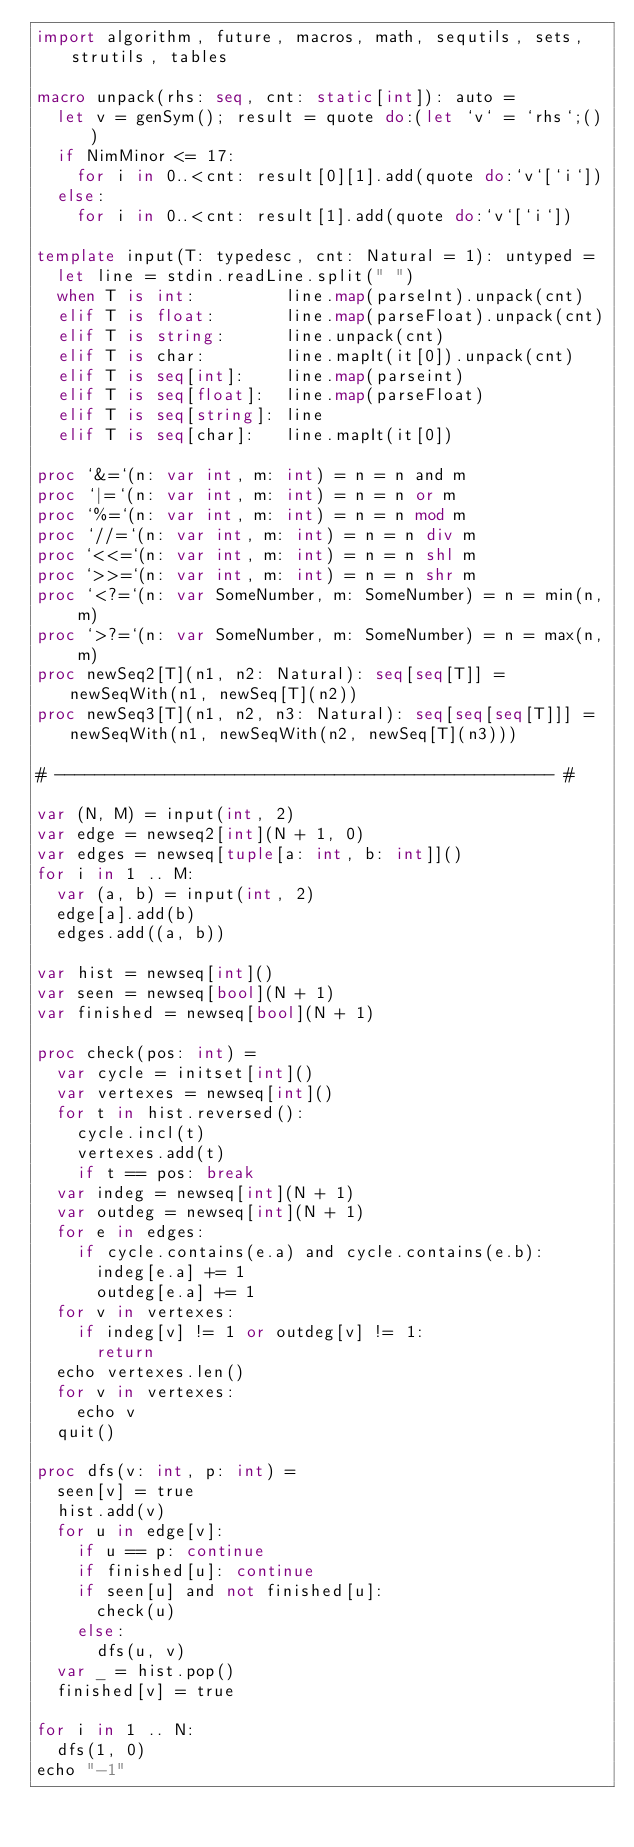<code> <loc_0><loc_0><loc_500><loc_500><_Nim_>import algorithm, future, macros, math, sequtils, sets, strutils, tables

macro unpack(rhs: seq, cnt: static[int]): auto =
  let v = genSym(); result = quote do:(let `v` = `rhs`;())
  if NimMinor <= 17:
    for i in 0..<cnt: result[0][1].add(quote do:`v`[`i`])
  else:
    for i in 0..<cnt: result[1].add(quote do:`v`[`i`])

template input(T: typedesc, cnt: Natural = 1): untyped =
  let line = stdin.readLine.split(" ")
  when T is int:         line.map(parseInt).unpack(cnt)
  elif T is float:       line.map(parseFloat).unpack(cnt)
  elif T is string:      line.unpack(cnt)
  elif T is char:        line.mapIt(it[0]).unpack(cnt)
  elif T is seq[int]:    line.map(parseint)
  elif T is seq[float]:  line.map(parseFloat)
  elif T is seq[string]: line
  elif T is seq[char]:   line.mapIt(it[0])

proc `&=`(n: var int, m: int) = n = n and m
proc `|=`(n: var int, m: int) = n = n or m
proc `%=`(n: var int, m: int) = n = n mod m
proc `//=`(n: var int, m: int) = n = n div m
proc `<<=`(n: var int, m: int) = n = n shl m
proc `>>=`(n: var int, m: int) = n = n shr m
proc `<?=`(n: var SomeNumber, m: SomeNumber) = n = min(n, m)
proc `>?=`(n: var SomeNumber, m: SomeNumber) = n = max(n, m)
proc newSeq2[T](n1, n2: Natural): seq[seq[T]] = newSeqWith(n1, newSeq[T](n2))
proc newSeq3[T](n1, n2, n3: Natural): seq[seq[seq[T]]] = newSeqWith(n1, newSeqWith(n2, newSeq[T](n3)))

# -------------------------------------------------- #

var (N, M) = input(int, 2)
var edge = newseq2[int](N + 1, 0)
var edges = newseq[tuple[a: int, b: int]]()
for i in 1 .. M:
  var (a, b) = input(int, 2)
  edge[a].add(b)
  edges.add((a, b))

var hist = newseq[int]()
var seen = newseq[bool](N + 1)
var finished = newseq[bool](N + 1)

proc check(pos: int) =
  var cycle = initset[int]()
  var vertexes = newseq[int]()
  for t in hist.reversed():
    cycle.incl(t)
    vertexes.add(t)
    if t == pos: break
  var indeg = newseq[int](N + 1)
  var outdeg = newseq[int](N + 1)
  for e in edges:
    if cycle.contains(e.a) and cycle.contains(e.b):
      indeg[e.a] += 1
      outdeg[e.a] += 1
  for v in vertexes:
    if indeg[v] != 1 or outdeg[v] != 1:
      return
  echo vertexes.len()
  for v in vertexes:
    echo v
  quit()

proc dfs(v: int, p: int) =
  seen[v] = true
  hist.add(v)
  for u in edge[v]:
    if u == p: continue
    if finished[u]: continue
    if seen[u] and not finished[u]:
      check(u)
    else:
      dfs(u, v)
  var _ = hist.pop()
  finished[v] = true

for i in 1 .. N:
  dfs(1, 0)
echo "-1"</code> 